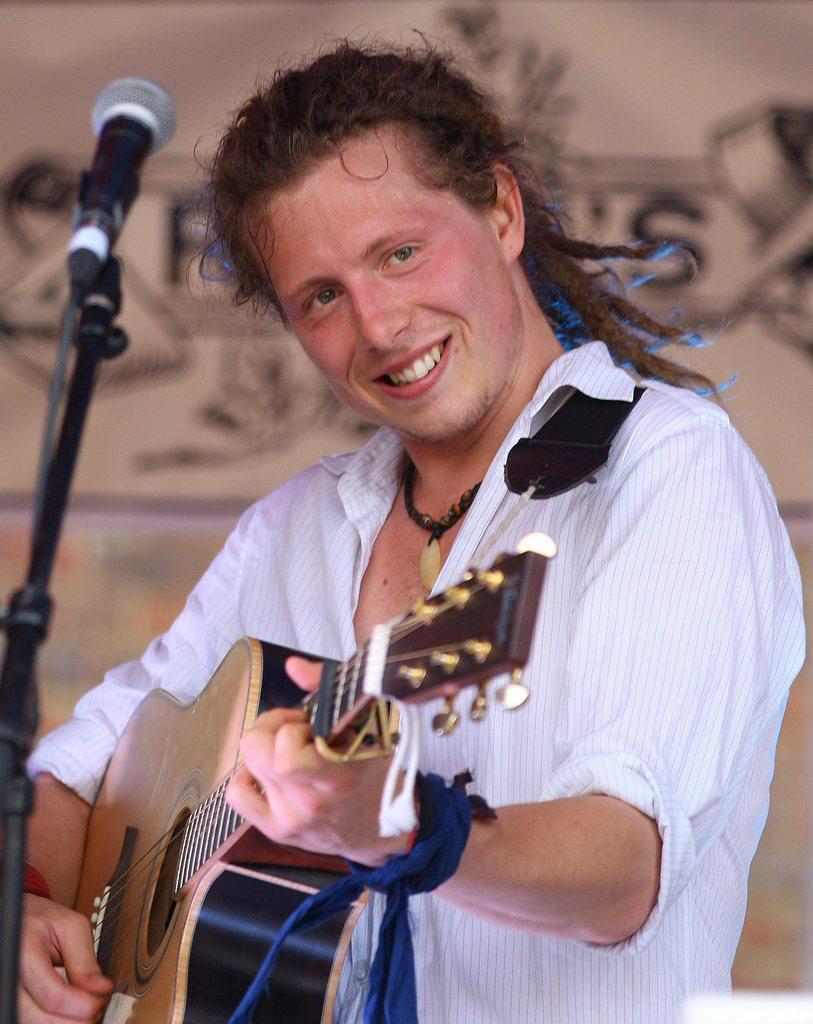Could you give a brief overview of what you see in this image? As we can see in the image there is a wall, mic and a man holding guitar. 